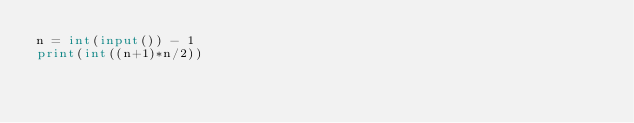<code> <loc_0><loc_0><loc_500><loc_500><_Python_>n = int(input()) - 1
print(int((n+1)*n/2))</code> 